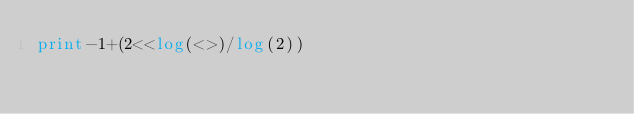Convert code to text. <code><loc_0><loc_0><loc_500><loc_500><_Perl_>print-1+(2<<log(<>)/log(2))</code> 